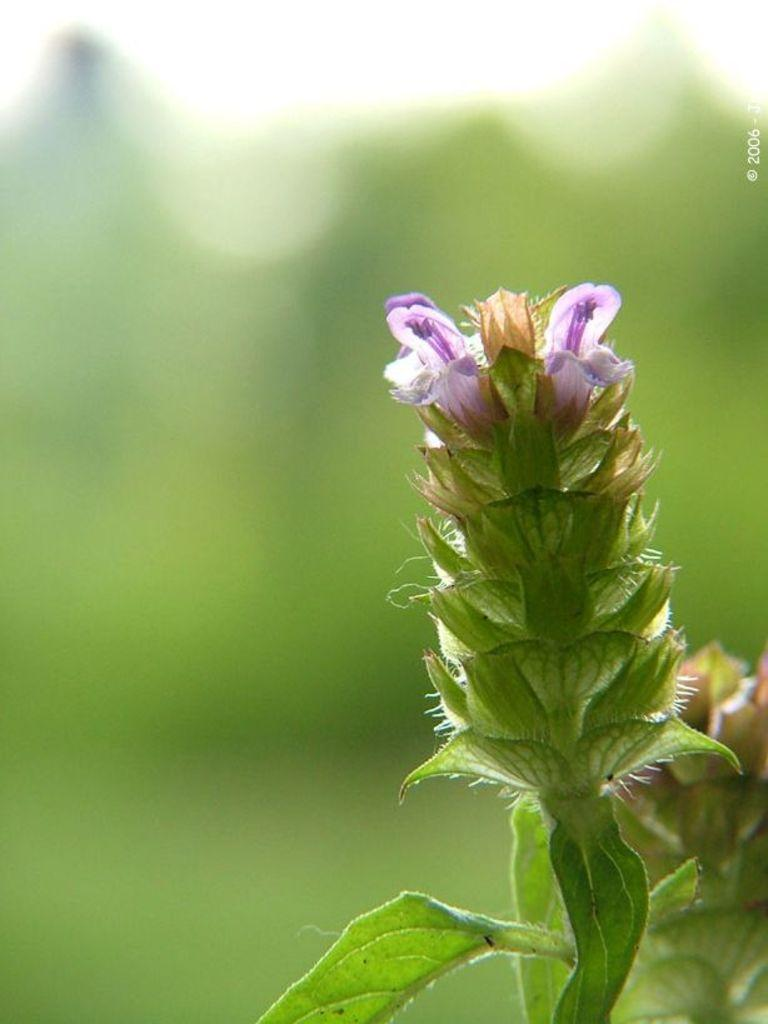What type of plant is visible in the image? There is a plant with flowers and leaves in the image. What color is predominant in the background of the image? The background of the image appears green. Where is the watermark located in the image? The watermark is on the right side of the image. How many icicles are hanging from the plant in the image? There are no icicles present in the image; it features a plant with flowers and leaves. What type of shake is being prepared in the image? There is no shake being prepared in the image; it only shows a plant with flowers and leaves. 